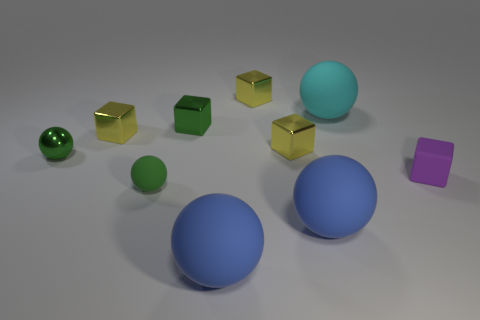There is a tiny rubber thing left of the cyan rubber sphere; what color is it?
Provide a succinct answer. Green. What number of small blue matte cubes are there?
Keep it short and to the point. 0. There is a green thing that is the same material as the large cyan ball; what shape is it?
Ensure brevity in your answer.  Sphere. Do the small matte object that is on the right side of the tiny green cube and the ball left of the tiny green rubber object have the same color?
Make the answer very short. No. Is the number of cyan rubber spheres that are behind the small purple thing the same as the number of cyan things?
Provide a short and direct response. Yes. What number of small matte objects are to the left of the purple object?
Provide a short and direct response. 1. How big is the green rubber ball?
Your answer should be very brief. Small. There is a sphere that is the same material as the green block; what color is it?
Ensure brevity in your answer.  Green. How many green metallic blocks are the same size as the purple cube?
Offer a very short reply. 1. Is the tiny yellow cube that is behind the cyan matte object made of the same material as the cyan ball?
Offer a terse response. No. 